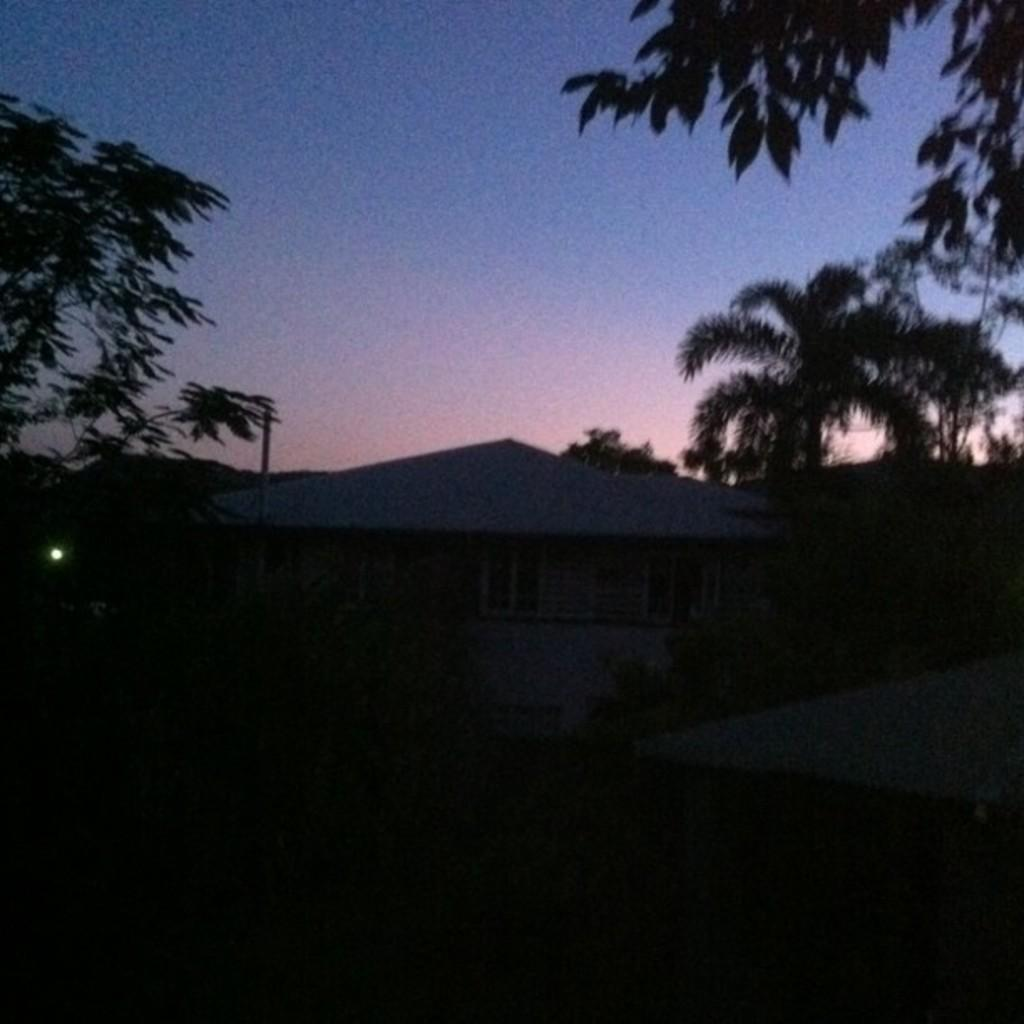What type of structure is present in the image? There is a house in the image. What other natural elements can be seen in the image? There are trees in the image. What is visible in the background of the image? The sky is visible in the background of the image. How many tramps are visible in the image? There are no tramps present in the image. What type of spiders can be seen crawling on the house in the image? There are no spiders visible in the image. 